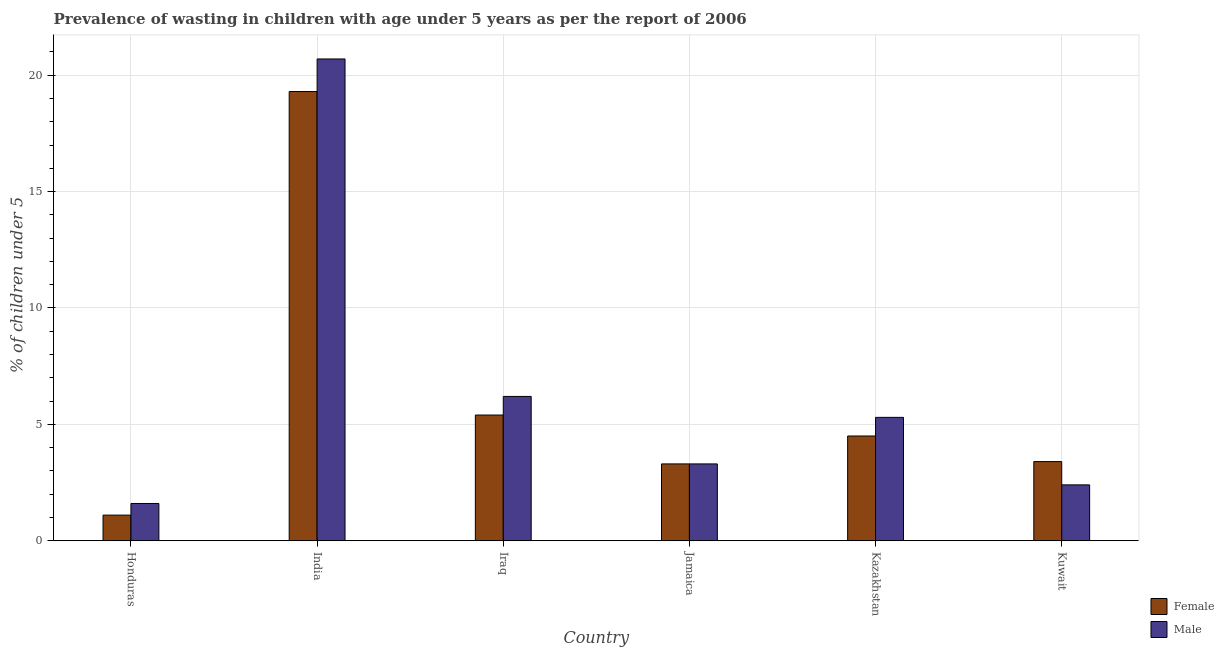Are the number of bars per tick equal to the number of legend labels?
Your answer should be very brief. Yes. Are the number of bars on each tick of the X-axis equal?
Give a very brief answer. Yes. How many bars are there on the 5th tick from the right?
Keep it short and to the point. 2. What is the label of the 6th group of bars from the left?
Keep it short and to the point. Kuwait. In how many cases, is the number of bars for a given country not equal to the number of legend labels?
Keep it short and to the point. 0. What is the percentage of undernourished male children in India?
Ensure brevity in your answer.  20.7. Across all countries, what is the maximum percentage of undernourished male children?
Offer a terse response. 20.7. Across all countries, what is the minimum percentage of undernourished female children?
Your response must be concise. 1.1. In which country was the percentage of undernourished female children minimum?
Provide a succinct answer. Honduras. What is the total percentage of undernourished male children in the graph?
Give a very brief answer. 39.5. What is the difference between the percentage of undernourished male children in Iraq and that in Kazakhstan?
Give a very brief answer. 0.9. What is the difference between the percentage of undernourished male children in Kazakhstan and the percentage of undernourished female children in Honduras?
Provide a succinct answer. 4.2. What is the average percentage of undernourished male children per country?
Offer a very short reply. 6.58. What is the difference between the percentage of undernourished female children and percentage of undernourished male children in India?
Ensure brevity in your answer.  -1.4. What is the ratio of the percentage of undernourished female children in India to that in Jamaica?
Provide a succinct answer. 5.85. What is the difference between the highest and the second highest percentage of undernourished male children?
Ensure brevity in your answer.  14.5. What is the difference between the highest and the lowest percentage of undernourished female children?
Keep it short and to the point. 18.2. Is the sum of the percentage of undernourished male children in India and Iraq greater than the maximum percentage of undernourished female children across all countries?
Your response must be concise. Yes. What does the 2nd bar from the right in Kazakhstan represents?
Offer a terse response. Female. Are all the bars in the graph horizontal?
Ensure brevity in your answer.  No. How many countries are there in the graph?
Keep it short and to the point. 6. Does the graph contain any zero values?
Your answer should be compact. No. How many legend labels are there?
Give a very brief answer. 2. How are the legend labels stacked?
Provide a short and direct response. Vertical. What is the title of the graph?
Your answer should be compact. Prevalence of wasting in children with age under 5 years as per the report of 2006. Does "Money lenders" appear as one of the legend labels in the graph?
Your answer should be very brief. No. What is the label or title of the X-axis?
Provide a short and direct response. Country. What is the label or title of the Y-axis?
Make the answer very short.  % of children under 5. What is the  % of children under 5 in Female in Honduras?
Ensure brevity in your answer.  1.1. What is the  % of children under 5 of Male in Honduras?
Provide a succinct answer. 1.6. What is the  % of children under 5 in Female in India?
Make the answer very short. 19.3. What is the  % of children under 5 of Male in India?
Your response must be concise. 20.7. What is the  % of children under 5 in Female in Iraq?
Provide a succinct answer. 5.4. What is the  % of children under 5 of Male in Iraq?
Your response must be concise. 6.2. What is the  % of children under 5 in Female in Jamaica?
Your answer should be compact. 3.3. What is the  % of children under 5 in Male in Jamaica?
Offer a terse response. 3.3. What is the  % of children under 5 of Male in Kazakhstan?
Provide a short and direct response. 5.3. What is the  % of children under 5 in Female in Kuwait?
Give a very brief answer. 3.4. What is the  % of children under 5 in Male in Kuwait?
Your answer should be very brief. 2.4. Across all countries, what is the maximum  % of children under 5 in Female?
Ensure brevity in your answer.  19.3. Across all countries, what is the maximum  % of children under 5 in Male?
Your answer should be very brief. 20.7. Across all countries, what is the minimum  % of children under 5 in Female?
Give a very brief answer. 1.1. Across all countries, what is the minimum  % of children under 5 in Male?
Provide a short and direct response. 1.6. What is the total  % of children under 5 of Male in the graph?
Provide a short and direct response. 39.5. What is the difference between the  % of children under 5 in Female in Honduras and that in India?
Your answer should be very brief. -18.2. What is the difference between the  % of children under 5 of Male in Honduras and that in India?
Your answer should be compact. -19.1. What is the difference between the  % of children under 5 in Male in Honduras and that in Iraq?
Ensure brevity in your answer.  -4.6. What is the difference between the  % of children under 5 in Female in Honduras and that in Jamaica?
Offer a very short reply. -2.2. What is the difference between the  % of children under 5 of Male in Honduras and that in Jamaica?
Keep it short and to the point. -1.7. What is the difference between the  % of children under 5 in Male in Honduras and that in Kazakhstan?
Your answer should be compact. -3.7. What is the difference between the  % of children under 5 of Male in Honduras and that in Kuwait?
Provide a succinct answer. -0.8. What is the difference between the  % of children under 5 in Female in India and that in Iraq?
Provide a short and direct response. 13.9. What is the difference between the  % of children under 5 of Male in India and that in Iraq?
Provide a succinct answer. 14.5. What is the difference between the  % of children under 5 in Female in India and that in Jamaica?
Provide a short and direct response. 16. What is the difference between the  % of children under 5 in Male in India and that in Jamaica?
Provide a short and direct response. 17.4. What is the difference between the  % of children under 5 in Female in India and that in Kazakhstan?
Offer a very short reply. 14.8. What is the difference between the  % of children under 5 of Male in India and that in Kazakhstan?
Make the answer very short. 15.4. What is the difference between the  % of children under 5 in Male in India and that in Kuwait?
Your response must be concise. 18.3. What is the difference between the  % of children under 5 of Male in Iraq and that in Jamaica?
Keep it short and to the point. 2.9. What is the difference between the  % of children under 5 of Female in Iraq and that in Kuwait?
Ensure brevity in your answer.  2. What is the difference between the  % of children under 5 of Male in Iraq and that in Kuwait?
Provide a short and direct response. 3.8. What is the difference between the  % of children under 5 of Female in Jamaica and that in Kazakhstan?
Make the answer very short. -1.2. What is the difference between the  % of children under 5 of Male in Jamaica and that in Kuwait?
Offer a terse response. 0.9. What is the difference between the  % of children under 5 of Female in Kazakhstan and that in Kuwait?
Offer a terse response. 1.1. What is the difference between the  % of children under 5 of Male in Kazakhstan and that in Kuwait?
Ensure brevity in your answer.  2.9. What is the difference between the  % of children under 5 of Female in Honduras and the  % of children under 5 of Male in India?
Offer a terse response. -19.6. What is the difference between the  % of children under 5 of Female in Honduras and the  % of children under 5 of Male in Iraq?
Make the answer very short. -5.1. What is the difference between the  % of children under 5 of Female in Honduras and the  % of children under 5 of Male in Jamaica?
Give a very brief answer. -2.2. What is the difference between the  % of children under 5 in Female in India and the  % of children under 5 in Male in Iraq?
Give a very brief answer. 13.1. What is the difference between the  % of children under 5 in Female in India and the  % of children under 5 in Male in Jamaica?
Your answer should be very brief. 16. What is the difference between the  % of children under 5 of Female in India and the  % of children under 5 of Male in Kazakhstan?
Offer a terse response. 14. What is the difference between the  % of children under 5 in Female in India and the  % of children under 5 in Male in Kuwait?
Provide a succinct answer. 16.9. What is the difference between the  % of children under 5 in Female in Iraq and the  % of children under 5 in Male in Kazakhstan?
Your answer should be very brief. 0.1. What is the difference between the  % of children under 5 of Female in Jamaica and the  % of children under 5 of Male in Kazakhstan?
Make the answer very short. -2. What is the difference between the  % of children under 5 in Female in Jamaica and the  % of children under 5 in Male in Kuwait?
Your response must be concise. 0.9. What is the average  % of children under 5 in Female per country?
Make the answer very short. 6.17. What is the average  % of children under 5 in Male per country?
Ensure brevity in your answer.  6.58. What is the difference between the  % of children under 5 in Female and  % of children under 5 in Male in Iraq?
Keep it short and to the point. -0.8. What is the difference between the  % of children under 5 in Female and  % of children under 5 in Male in Jamaica?
Offer a terse response. 0. What is the difference between the  % of children under 5 of Female and  % of children under 5 of Male in Kazakhstan?
Give a very brief answer. -0.8. What is the difference between the  % of children under 5 in Female and  % of children under 5 in Male in Kuwait?
Ensure brevity in your answer.  1. What is the ratio of the  % of children under 5 in Female in Honduras to that in India?
Ensure brevity in your answer.  0.06. What is the ratio of the  % of children under 5 of Male in Honduras to that in India?
Provide a succinct answer. 0.08. What is the ratio of the  % of children under 5 of Female in Honduras to that in Iraq?
Ensure brevity in your answer.  0.2. What is the ratio of the  % of children under 5 of Male in Honduras to that in Iraq?
Provide a succinct answer. 0.26. What is the ratio of the  % of children under 5 of Female in Honduras to that in Jamaica?
Keep it short and to the point. 0.33. What is the ratio of the  % of children under 5 in Male in Honduras to that in Jamaica?
Provide a short and direct response. 0.48. What is the ratio of the  % of children under 5 in Female in Honduras to that in Kazakhstan?
Ensure brevity in your answer.  0.24. What is the ratio of the  % of children under 5 in Male in Honduras to that in Kazakhstan?
Ensure brevity in your answer.  0.3. What is the ratio of the  % of children under 5 in Female in Honduras to that in Kuwait?
Offer a very short reply. 0.32. What is the ratio of the  % of children under 5 of Female in India to that in Iraq?
Give a very brief answer. 3.57. What is the ratio of the  % of children under 5 in Male in India to that in Iraq?
Your answer should be compact. 3.34. What is the ratio of the  % of children under 5 in Female in India to that in Jamaica?
Keep it short and to the point. 5.85. What is the ratio of the  % of children under 5 in Male in India to that in Jamaica?
Provide a succinct answer. 6.27. What is the ratio of the  % of children under 5 of Female in India to that in Kazakhstan?
Make the answer very short. 4.29. What is the ratio of the  % of children under 5 in Male in India to that in Kazakhstan?
Your answer should be very brief. 3.91. What is the ratio of the  % of children under 5 in Female in India to that in Kuwait?
Offer a terse response. 5.68. What is the ratio of the  % of children under 5 of Male in India to that in Kuwait?
Your answer should be very brief. 8.62. What is the ratio of the  % of children under 5 in Female in Iraq to that in Jamaica?
Your answer should be very brief. 1.64. What is the ratio of the  % of children under 5 of Male in Iraq to that in Jamaica?
Your answer should be very brief. 1.88. What is the ratio of the  % of children under 5 of Male in Iraq to that in Kazakhstan?
Provide a short and direct response. 1.17. What is the ratio of the  % of children under 5 of Female in Iraq to that in Kuwait?
Provide a short and direct response. 1.59. What is the ratio of the  % of children under 5 of Male in Iraq to that in Kuwait?
Provide a short and direct response. 2.58. What is the ratio of the  % of children under 5 of Female in Jamaica to that in Kazakhstan?
Ensure brevity in your answer.  0.73. What is the ratio of the  % of children under 5 of Male in Jamaica to that in Kazakhstan?
Offer a terse response. 0.62. What is the ratio of the  % of children under 5 in Female in Jamaica to that in Kuwait?
Provide a succinct answer. 0.97. What is the ratio of the  % of children under 5 of Male in Jamaica to that in Kuwait?
Provide a short and direct response. 1.38. What is the ratio of the  % of children under 5 in Female in Kazakhstan to that in Kuwait?
Offer a terse response. 1.32. What is the ratio of the  % of children under 5 in Male in Kazakhstan to that in Kuwait?
Offer a very short reply. 2.21. What is the difference between the highest and the second highest  % of children under 5 in Male?
Your answer should be compact. 14.5. What is the difference between the highest and the lowest  % of children under 5 in Female?
Your response must be concise. 18.2. What is the difference between the highest and the lowest  % of children under 5 of Male?
Offer a very short reply. 19.1. 